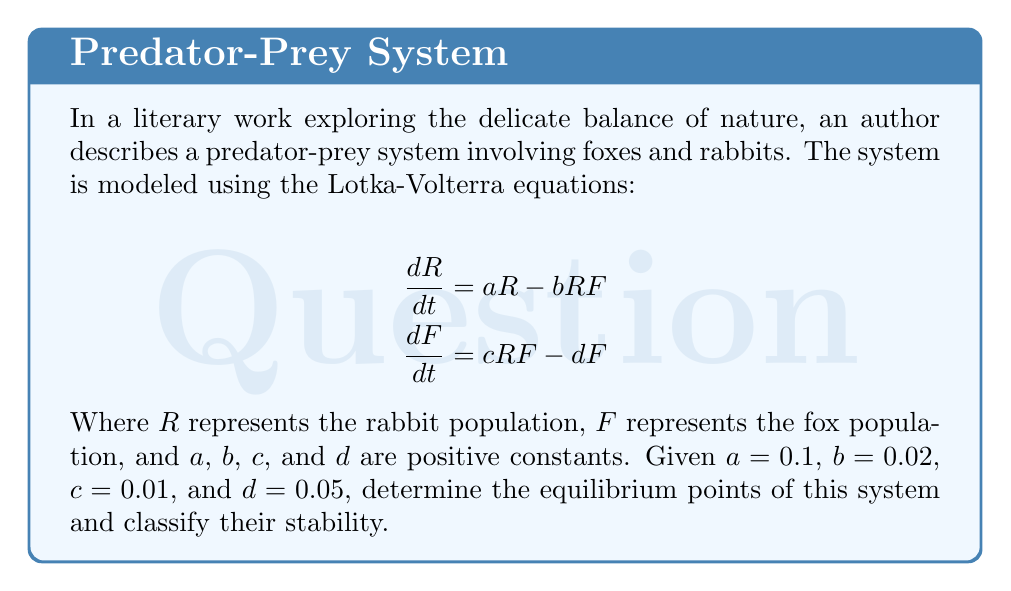Teach me how to tackle this problem. To solve this problem, we'll follow these steps:

1. Find the equilibrium points by setting both equations to zero.
2. Analyze the stability of each equilibrium point using the Jacobian matrix.

Step 1: Finding equilibrium points

Set both equations to zero:

$$0 = aR - bRF$$
$$0 = cRF - dF$$

From the second equation:
$$cRF = dF$$
$$cR = d$$ (if $F \neq 0$)
$$R = \frac{d}{c} = \frac{0.05}{0.01} = 5$$

From the first equation:
$$aR = bRF$$
$$a = bF$$ (if $R \neq 0$)
$$F = \frac{a}{b} = \frac{0.1}{0.02} = 5$$

We also have the trivial equilibrium point $(0, 0)$.

Therefore, the equilibrium points are $(0, 0)$ and $(5, 5)$.

Step 2: Analyzing stability

To analyze stability, we need to calculate the Jacobian matrix:

$$J = \begin{bmatrix}
\frac{\partial}{\partial R}(aR - bRF) & \frac{\partial}{\partial F}(aR - bRF) \\
\frac{\partial}{\partial R}(cRF - dF) & \frac{\partial}{\partial F}(cRF - dF)
\end{bmatrix}$$

$$J = \begin{bmatrix}
a - bF & -bR \\
cF & cR - d
\end{bmatrix}$$

For $(0, 0)$:
$$J_{(0,0)} = \begin{bmatrix}
0.1 & 0 \\
0 & -0.05
\end{bmatrix}$$

The eigenvalues are 0.1 and -0.05. Since one eigenvalue is positive, $(0, 0)$ is an unstable saddle point.

For $(5, 5)$:
$$J_{(5,5)} = \begin{bmatrix}
0 & -0.1 \\
0.05 & 0
\end{bmatrix}$$

The eigenvalues are $\pm i\sqrt{0.005}$. These are purely imaginary, indicating that $(5, 5)$ is a center (neutrally stable).
Answer: The system has two equilibrium points: $(0, 0)$ and $(5, 5)$. The point $(0, 0)$ is an unstable saddle point, while $(5, 5)$ is a neutrally stable center. 